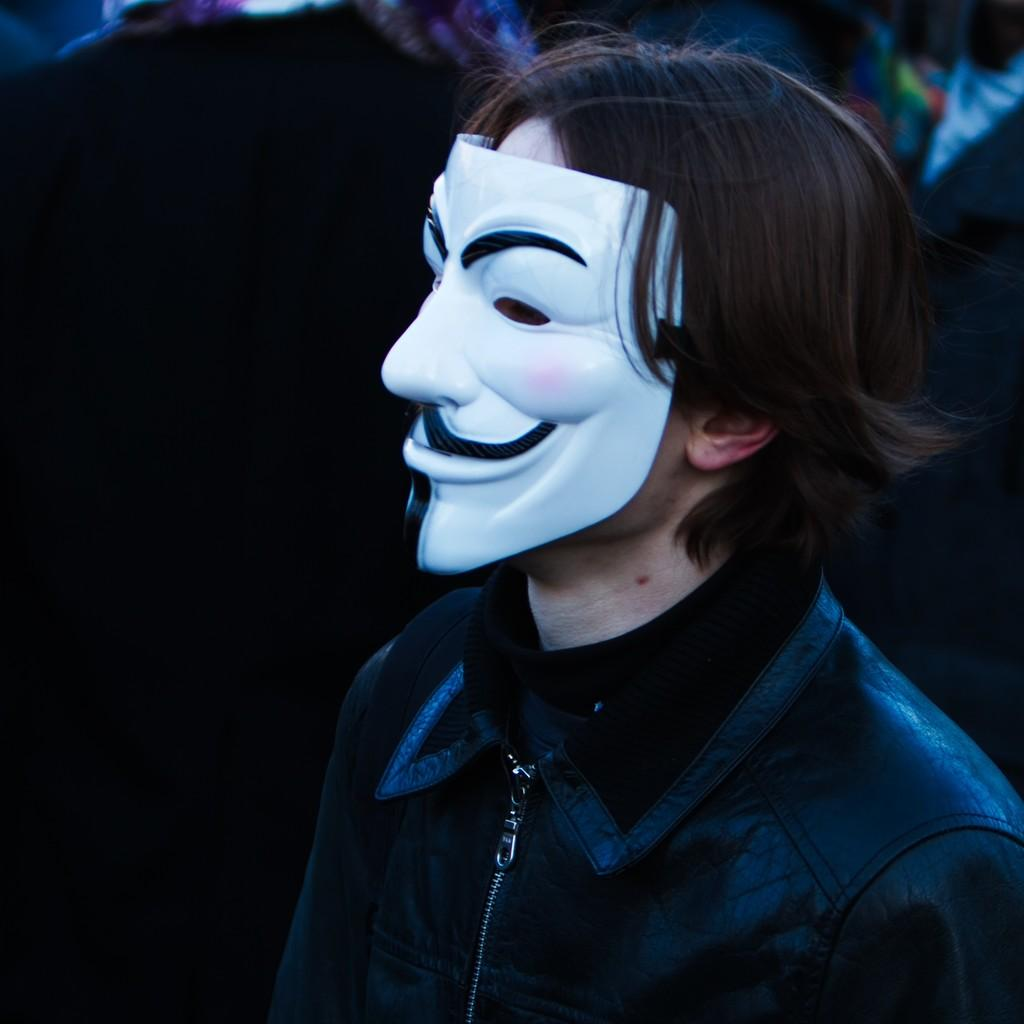Who or what is the main subject of the image? There is a person in the image. What is the person wearing on their face? The person is wearing a mask. Can you describe the background of the image? The background of the image is blurred. What type of clam can be seen on the top of the person's head in the image? There is no clam present on the person's head or anywhere else in the image. 